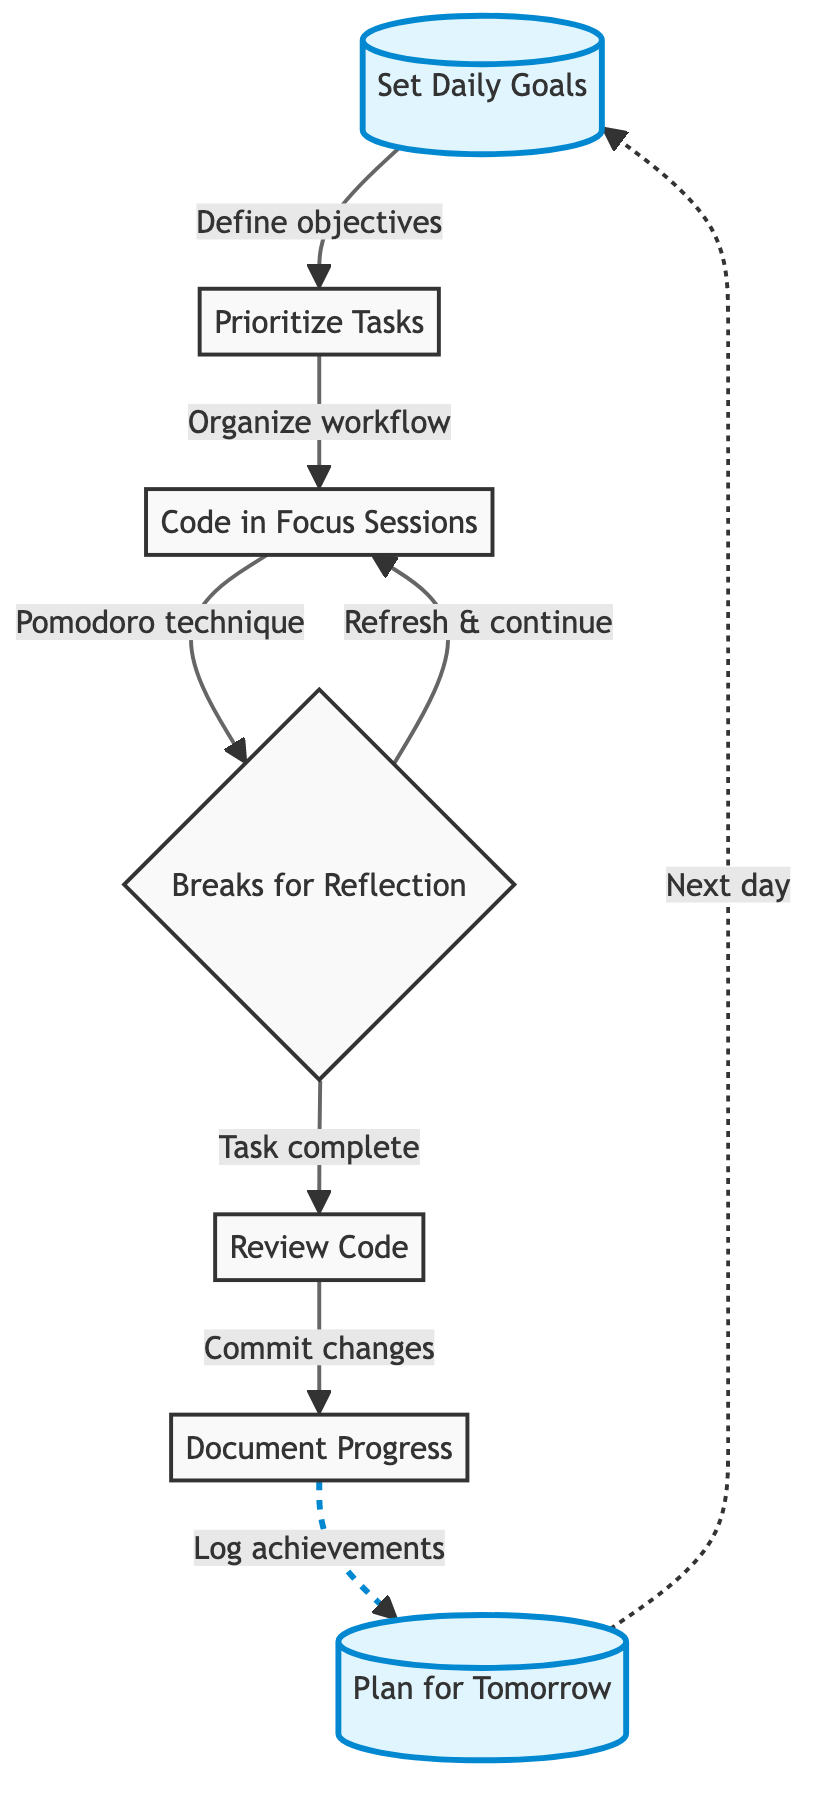What is the first step in the daily productivity workflow? The flow chart starts with "Set Daily Goals," which is positioned at the top of the diagram as the initial step in the process.
Answer: Set Daily Goals What is the last step in the daily productivity workflow? The final step in the flow chart is "Plan for Tomorrow," which appears at the bottom and links back to the initial step.
Answer: Plan for Tomorrow How many main steps are there in the diagram? To determine the number of main steps, we can count each distinct node in the flow chart, which totals seven unique processes.
Answer: 7 Which task comes directly after "Prioritize Tasks"? Following "Prioritize Tasks," the next task is "Code in Focus Sessions," indicated by an arrow showing the flow from one step to the next.
Answer: Code in Focus Sessions What is the relationship between "Breaks for Reflection" and "Code in Focus Sessions"? "Breaks for Reflection" is a decision point that leads to two outcomes: returning to "Code in Focus Sessions" to "Refresh & continue" or moving forward to "Review Code" when a task is complete.
Answer: Two outcomes Which nodes are marked as highlights in the diagram? The highlighted nodes in the flow chart are "Set Daily Goals" and "Plan for Tomorrow," distinguished by a different color and style.
Answer: Set Daily Goals, Plan for Tomorrow How do you conclude the day's workflow according to the chart? The conclusion of the day's workflow is represented as "Plan for Tomorrow," where the programmer outlines tasks for the next day, preparing for continued productivity.
Answer: Plan for Tomorrow Is there a feedback loop in the diagram? Yes, there is a feedback loop since the process flows back from "Plan for Tomorrow" to "Set Daily Goals," creating a continuous cycle in the workflow.
Answer: Yes What technique is suggested for focused coding sessions? The Pomodoro Technique is recommended for maintaining focus during coding sessions, as specified in the description of the "Code in Focus Sessions" node.
Answer: Pomodoro Technique 